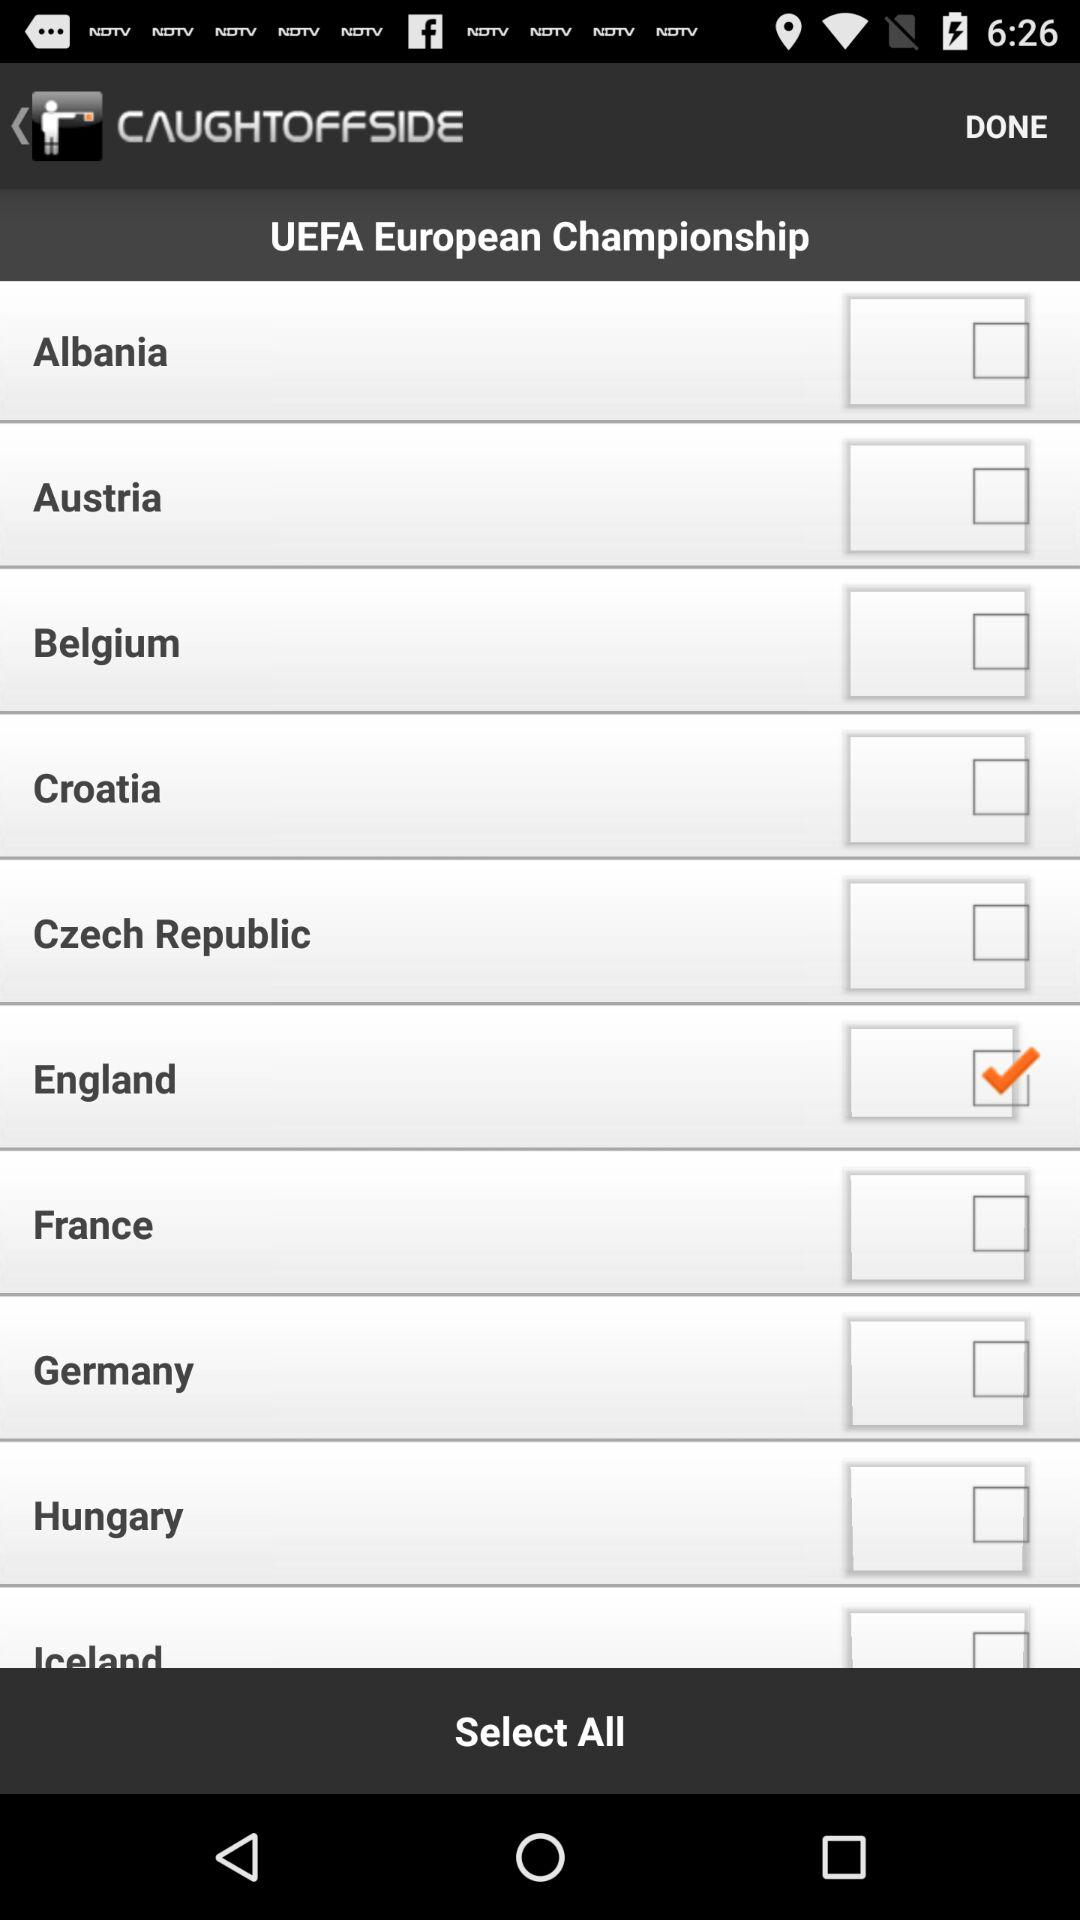Which option is checked? The checked option is "England". 